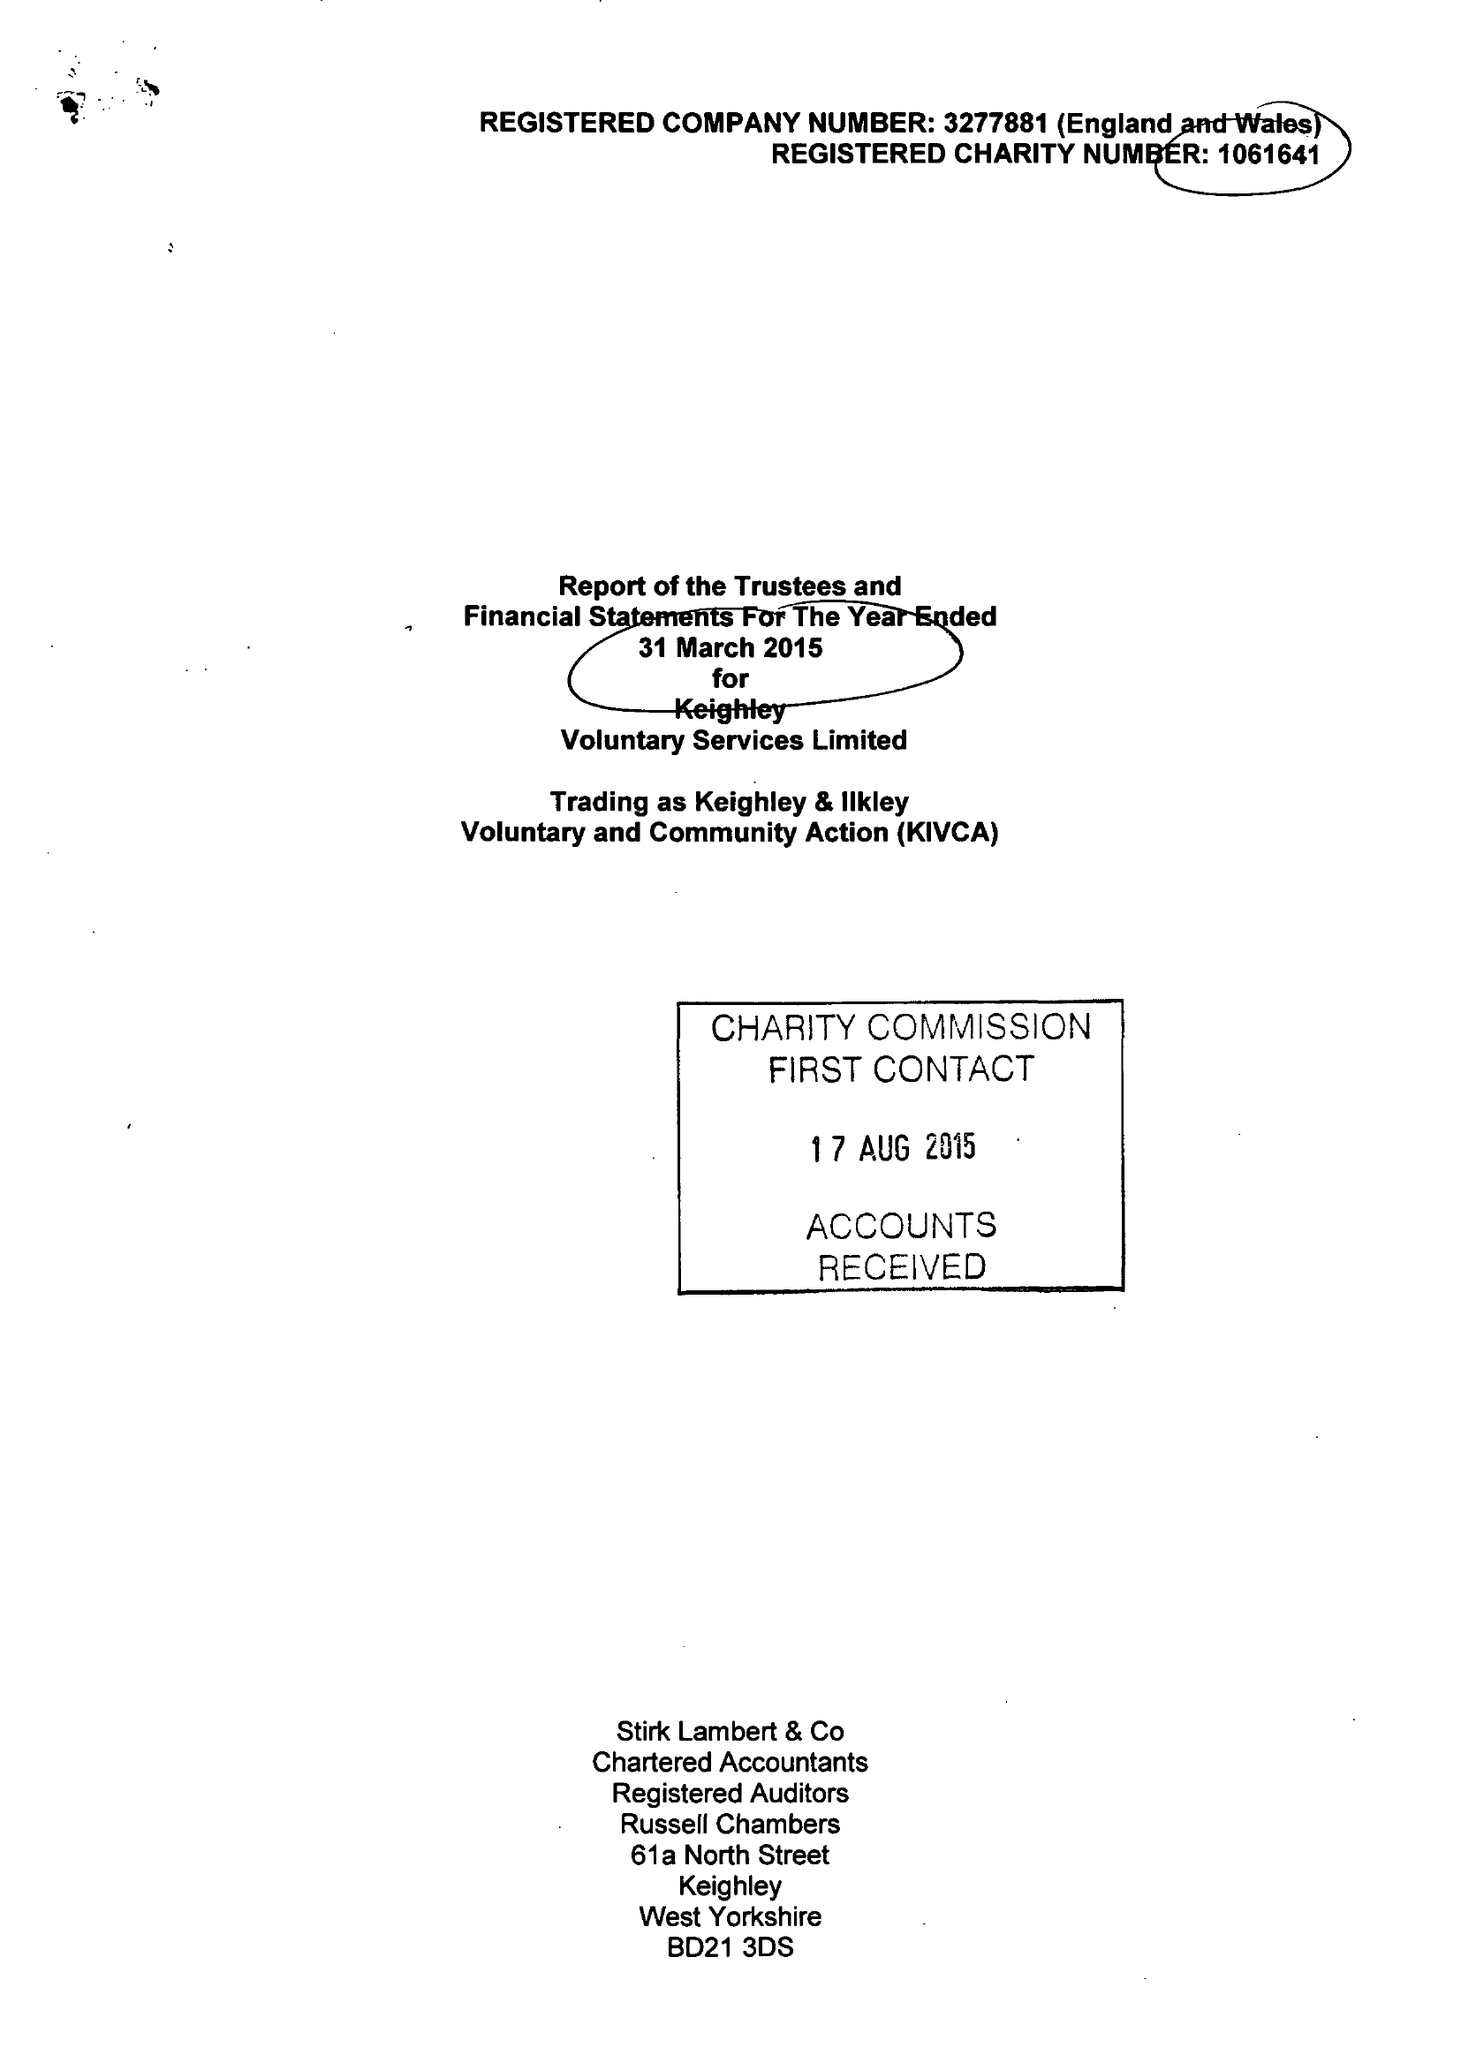What is the value for the spending_annually_in_british_pounds?
Answer the question using a single word or phrase. 947016.00 